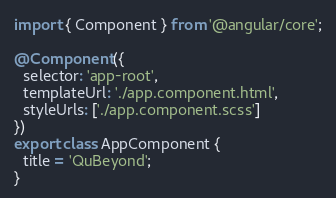<code> <loc_0><loc_0><loc_500><loc_500><_TypeScript_>import { Component } from '@angular/core';

@Component({
  selector: 'app-root',
  templateUrl: './app.component.html',
  styleUrls: ['./app.component.scss']
})
export class AppComponent {
  title = 'QuBeyond';
}
</code> 